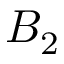Convert formula to latex. <formula><loc_0><loc_0><loc_500><loc_500>B _ { 2 }</formula> 